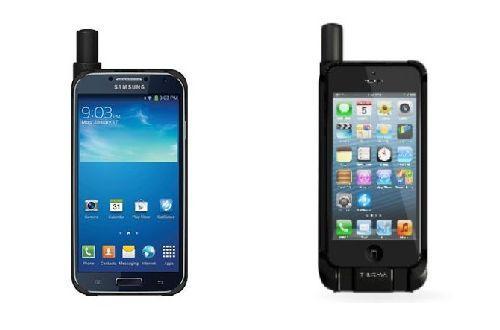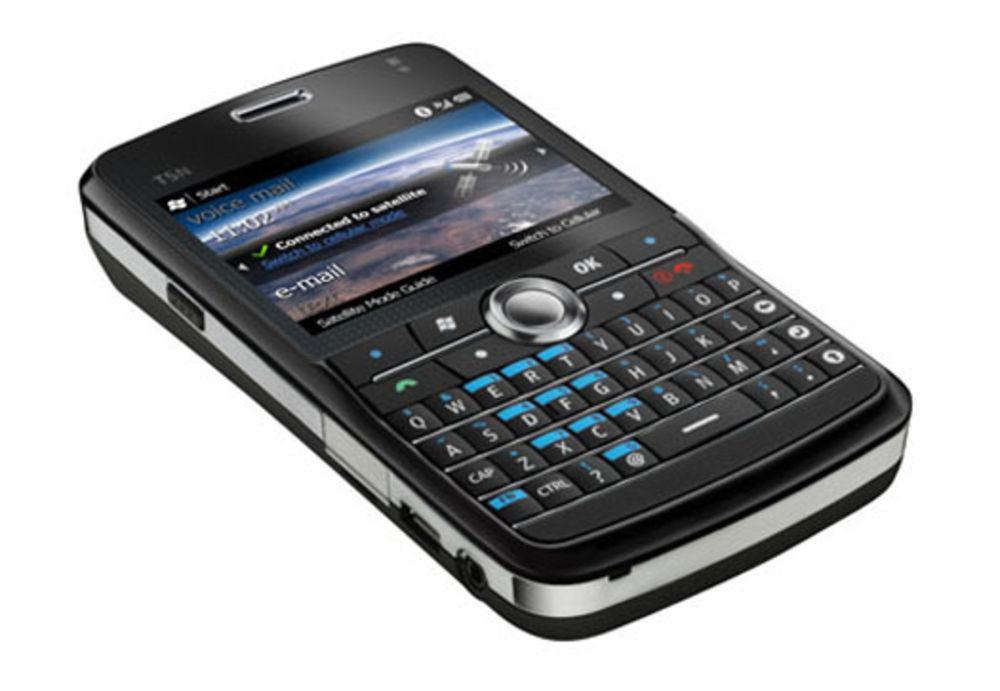The first image is the image on the left, the second image is the image on the right. Evaluate the accuracy of this statement regarding the images: "One image contains a single black device, which is upright and has a rod-shape extending diagonally from its top.". Is it true? Answer yes or no. No. The first image is the image on the left, the second image is the image on the right. Examine the images to the left and right. Is the description "There are at least three phones." accurate? Answer yes or no. Yes. 